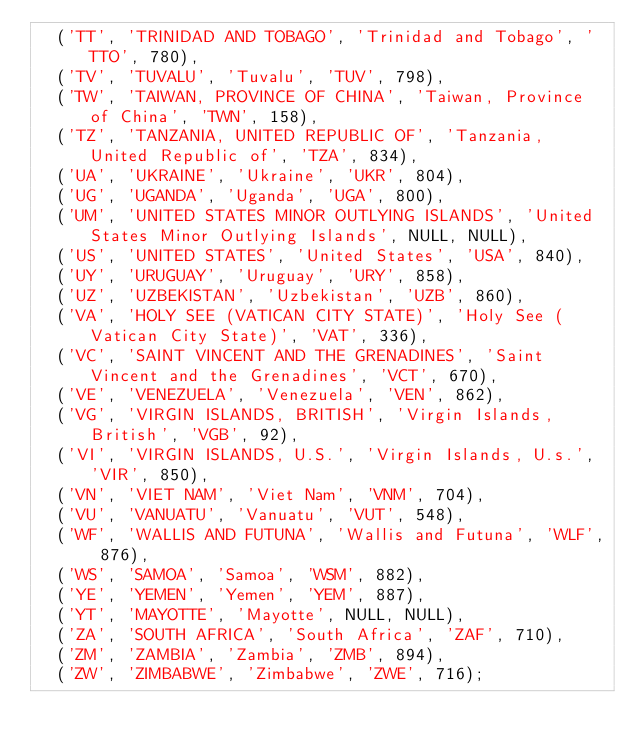Convert code to text. <code><loc_0><loc_0><loc_500><loc_500><_SQL_>	('TT', 'TRINIDAD AND TOBAGO', 'Trinidad and Tobago', 'TTO', 780),
	('TV', 'TUVALU', 'Tuvalu', 'TUV', 798),
	('TW', 'TAIWAN, PROVINCE OF CHINA', 'Taiwan, Province of China', 'TWN', 158),
	('TZ', 'TANZANIA, UNITED REPUBLIC OF', 'Tanzania, United Republic of', 'TZA', 834),
	('UA', 'UKRAINE', 'Ukraine', 'UKR', 804),
	('UG', 'UGANDA', 'Uganda', 'UGA', 800),
	('UM', 'UNITED STATES MINOR OUTLYING ISLANDS', 'United States Minor Outlying Islands', NULL, NULL),
	('US', 'UNITED STATES', 'United States', 'USA', 840),
	('UY', 'URUGUAY', 'Uruguay', 'URY', 858),
	('UZ', 'UZBEKISTAN', 'Uzbekistan', 'UZB', 860),
	('VA', 'HOLY SEE (VATICAN CITY STATE)', 'Holy See (Vatican City State)', 'VAT', 336),
	('VC', 'SAINT VINCENT AND THE GRENADINES', 'Saint Vincent and the Grenadines', 'VCT', 670),
	('VE', 'VENEZUELA', 'Venezuela', 'VEN', 862),
	('VG', 'VIRGIN ISLANDS, BRITISH', 'Virgin Islands, British', 'VGB', 92),
	('VI', 'VIRGIN ISLANDS, U.S.', 'Virgin Islands, U.s.', 'VIR', 850),
	('VN', 'VIET NAM', 'Viet Nam', 'VNM', 704),
	('VU', 'VANUATU', 'Vanuatu', 'VUT', 548),
	('WF', 'WALLIS AND FUTUNA', 'Wallis and Futuna', 'WLF', 876),
	('WS', 'SAMOA', 'Samoa', 'WSM', 882),
	('YE', 'YEMEN', 'Yemen', 'YEM', 887),
	('YT', 'MAYOTTE', 'Mayotte', NULL, NULL),
	('ZA', 'SOUTH AFRICA', 'South Africa', 'ZAF', 710),
	('ZM', 'ZAMBIA', 'Zambia', 'ZMB', 894),
	('ZW', 'ZIMBABWE', 'Zimbabwe', 'ZWE', 716);</code> 